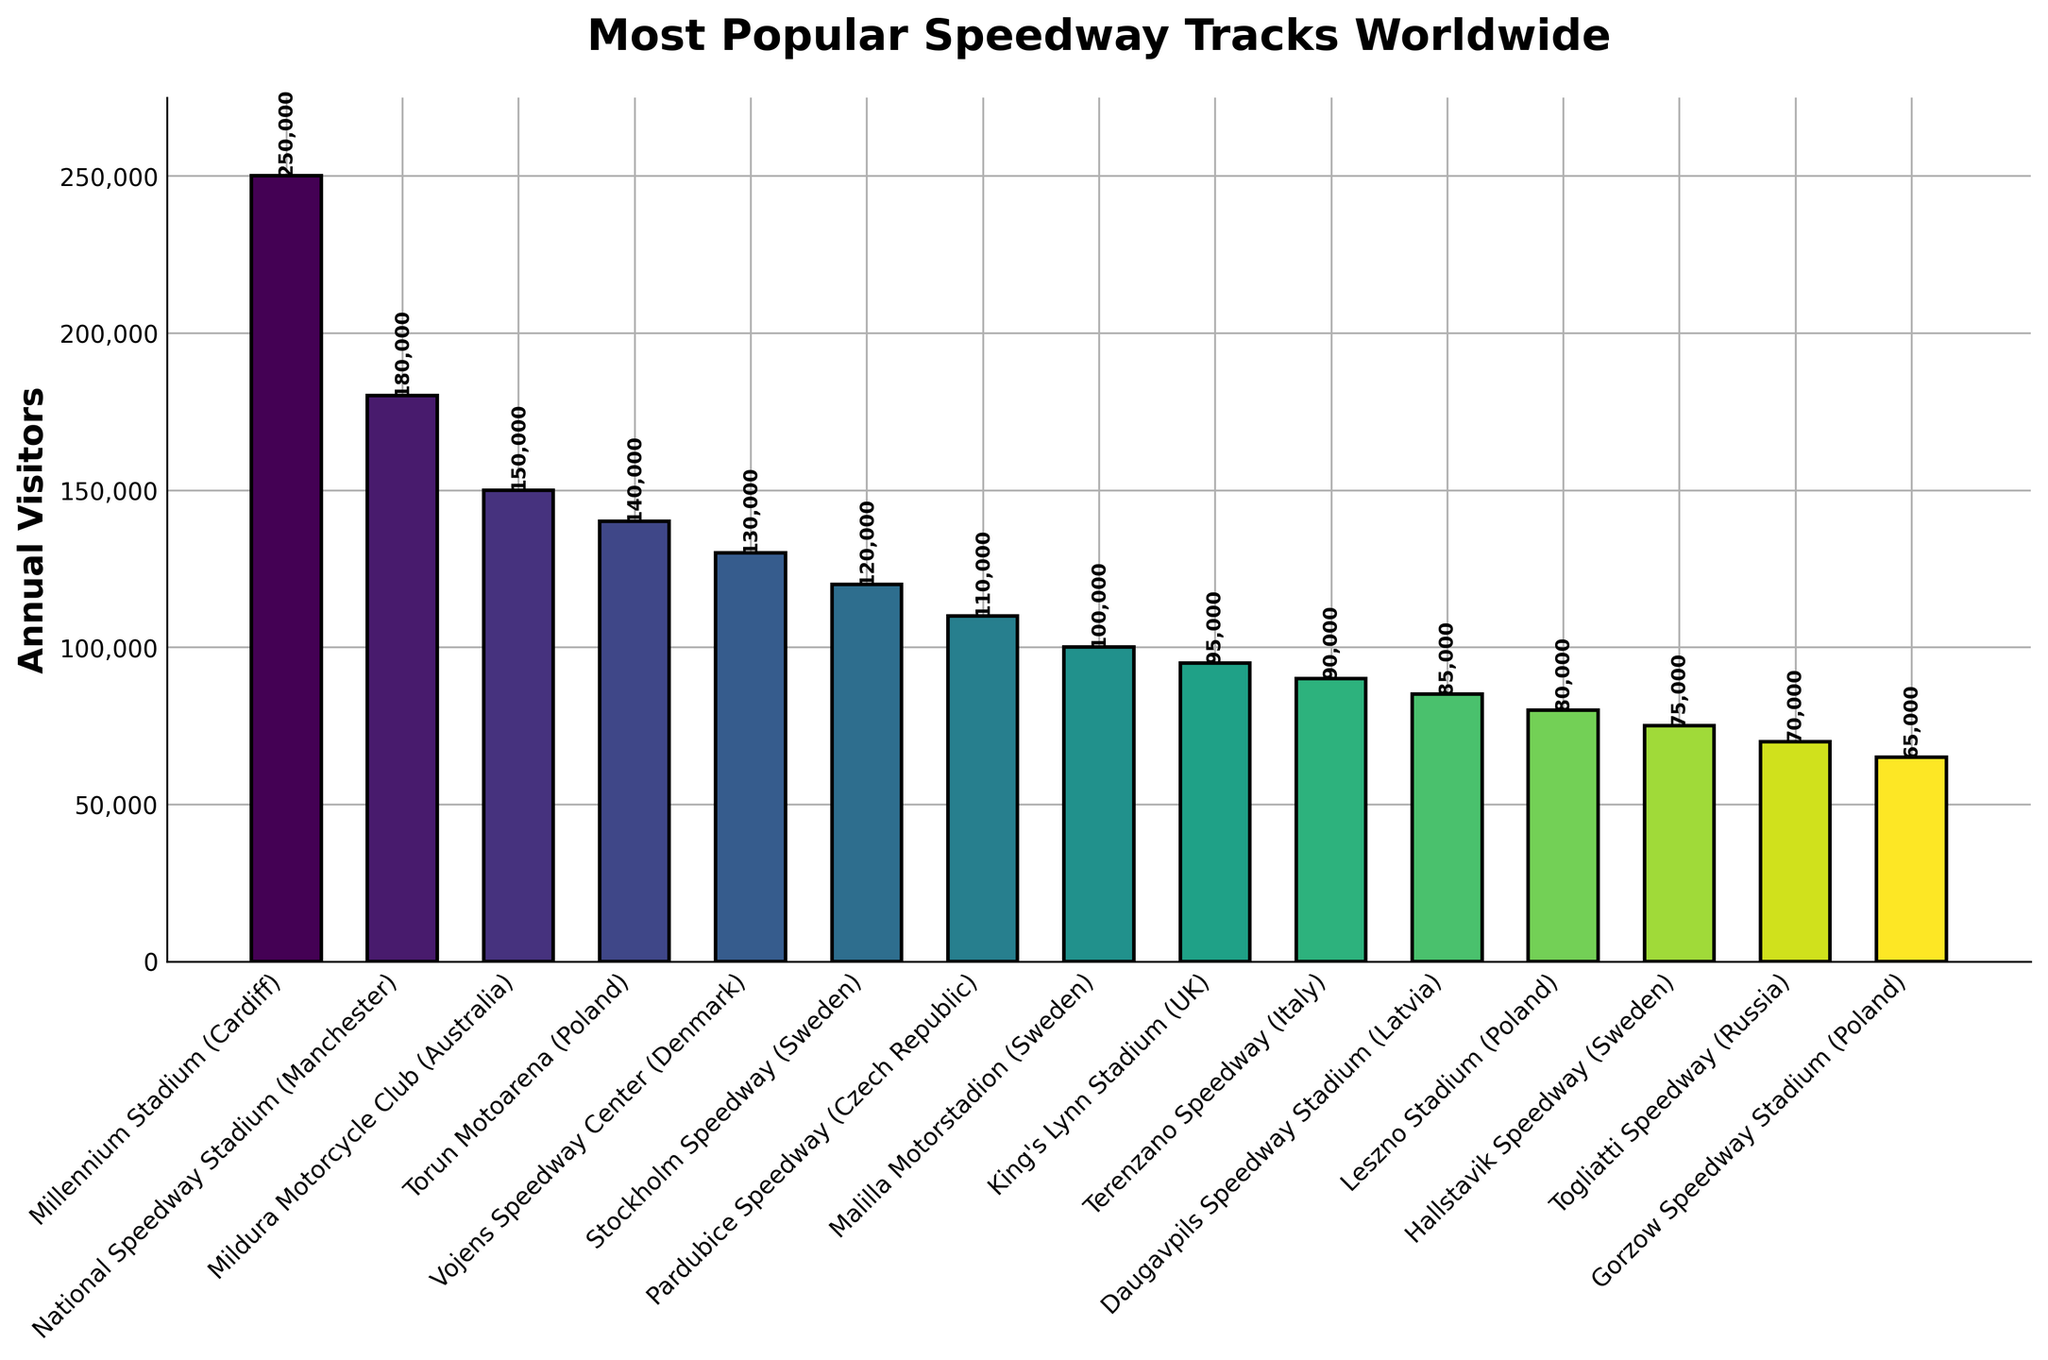Which track has the highest annual visitors? The plot shows the visitor counts for each track, the bar representing the Millennium Stadium (Cardiff) is the tallest, indicating it has the highest number of annual visitors.
Answer: Millennium Stadium (Cardiff) Which two tracks have the same region (Sweden) with different visitor counts? Visual inspection shows that there are multiple tracks from Sweden: Stockholm Speedway and Hallstavik Speedway. Their bars differ in height, indicating different visitor counts.
Answer: Stockholm Speedway and Hallstavik Speedway What is the difference in annual visitors between the top two tracks? The Millennium Stadium (Cardiff) has 250,000 visitors and the National Speedway Stadium (Manchester) has 180,000 visitors. The difference is 250,000 - 180,000.
Answer: 70,000 Which speedway track has the lowest annual visitors? The shortest bar corresponds to the Gorzow Speedway Stadium (Poland), indicating it has the lowest number of annual visitors.
Answer: Gorzow Speedway Stadium (Poland) How many more annual visitors does Torun Motoarena (Poland) have compared to Leszno Stadium (Poland)? The bar for Torun Motoarena shows 140,000 visitors, while the bar for Leszno Stadium shows 80,000 visitors. The difference is 140,000 - 80,000.
Answer: 60,000 What is the total number of annual visitors of the tracks in Sweden? There are three tracks from Sweden: Stockholm Speedway (120,000), Malilla Motorstadion (100,000), and Hallstavik Speedway (75,000). Sum these values: 120,000 + 100,000 + 75,000.
Answer: 295,000 Which country's tracks have the highest combined visitor count? (Consider the sum of all tracks from the same country) Identify the countries: Poland (Torun Motoarena 140,000 + Leszno Stadium 80,000 + Gorzow Speedway Stadium 65,000), Sweden (Stockholm Speedway 120,000 + Malilla Motorstadion 100,000 + Hallstavik Speedway 75,000), and so on. Calculate the sums and compare.
Answer: Poland What is the average number of annual visitors for the tracks listed? Sum up the visitor counts for all tracks and divide by the number of tracks: (250,000 + 180,000 + … + 65,000) / 15.
Answer: 118,333 How does the annual visitor count of King's Lynn Stadium (UK) compare to Terenzano Speedway (Italy)? The bar for King's Lynn Stadium shows 95,000 visitors, while the bar for Terenzano Speedway shows 90,000 visitors. Compare the two values.
Answer: King's Lynn Stadium has 5,000 more visitors 